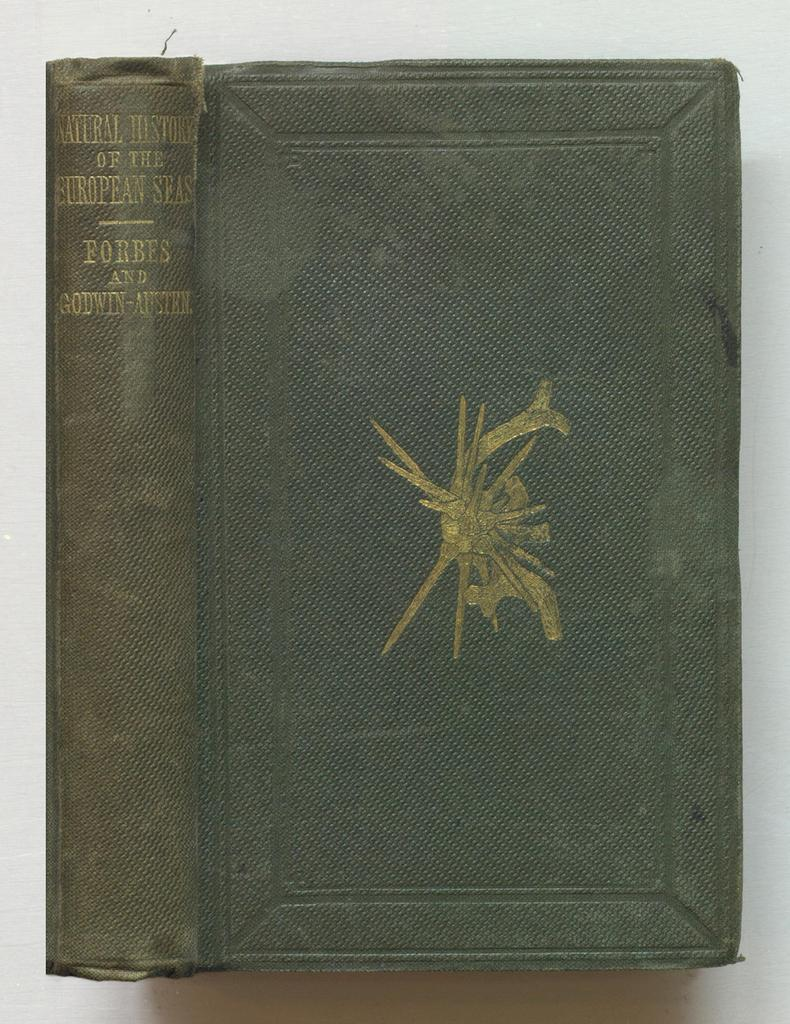Provide a one-sentence caption for the provided image. The Natural History of the European Seas book has a discolored spine. 